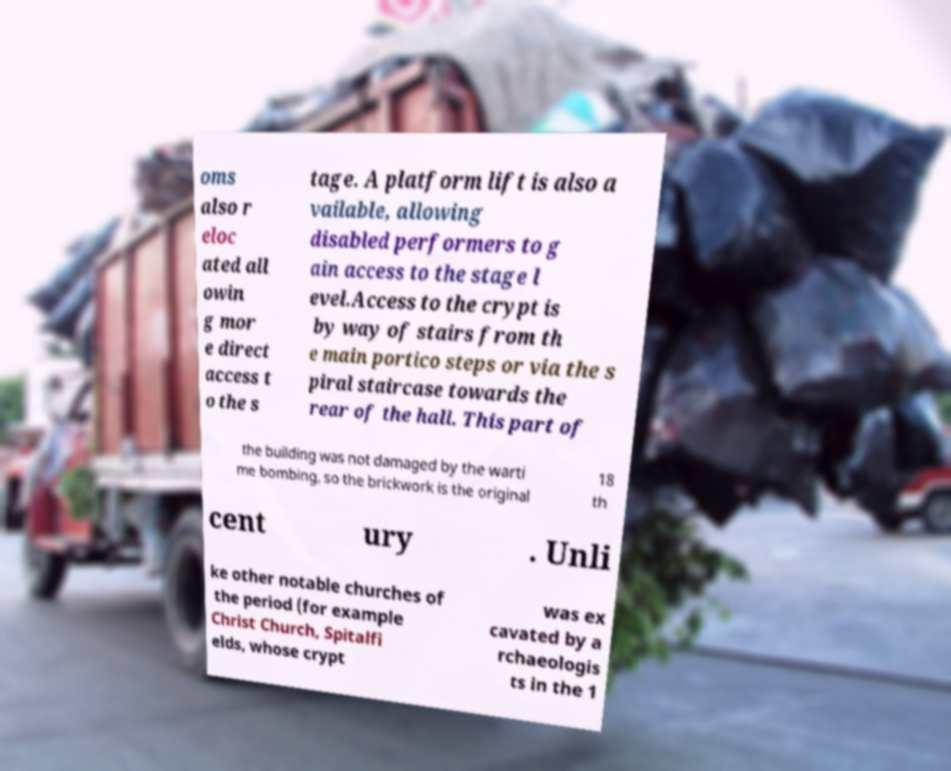There's text embedded in this image that I need extracted. Can you transcribe it verbatim? oms also r eloc ated all owin g mor e direct access t o the s tage. A platform lift is also a vailable, allowing disabled performers to g ain access to the stage l evel.Access to the crypt is by way of stairs from th e main portico steps or via the s piral staircase towards the rear of the hall. This part of the building was not damaged by the warti me bombing, so the brickwork is the original 18 th cent ury . Unli ke other notable churches of the period (for example Christ Church, Spitalfi elds, whose crypt was ex cavated by a rchaeologis ts in the 1 